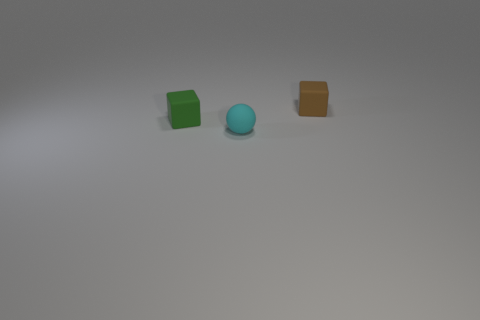Are there any other rubber balls of the same color as the tiny matte ball?
Keep it short and to the point. No. What is the shape of the brown object that is the same size as the green matte thing?
Provide a succinct answer. Cube. Is the number of tiny brown rubber spheres less than the number of tiny rubber things?
Your answer should be very brief. Yes. What number of other things are the same size as the brown thing?
Provide a short and direct response. 2. What is the small green block made of?
Your answer should be very brief. Rubber. There is a cube that is in front of the tiny brown object; what size is it?
Provide a short and direct response. Small. What number of cyan matte objects are the same shape as the small brown thing?
Make the answer very short. 0. What shape is the small cyan object that is the same material as the small green thing?
Your response must be concise. Sphere. How many cyan things are tiny matte objects or cubes?
Your response must be concise. 1. There is a small brown thing; are there any blocks in front of it?
Your answer should be very brief. Yes. 